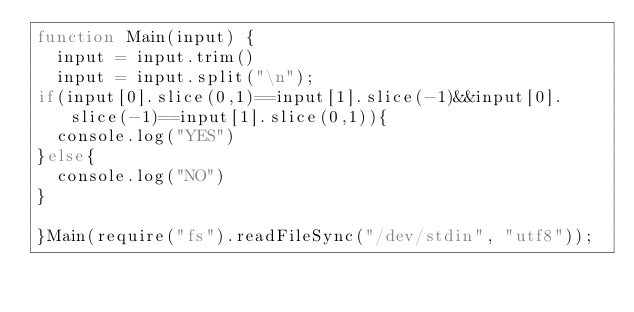Convert code to text. <code><loc_0><loc_0><loc_500><loc_500><_JavaScript_>function Main(input) {
  input = input.trim()
  input = input.split("\n");
if(input[0].slice(0,1)==input[1].slice(-1)&&input[0].slice(-1)==input[1].slice(0,1)){
  console.log("YES")
}else{
  console.log("NO")
}

}Main(require("fs").readFileSync("/dev/stdin", "utf8"));
</code> 